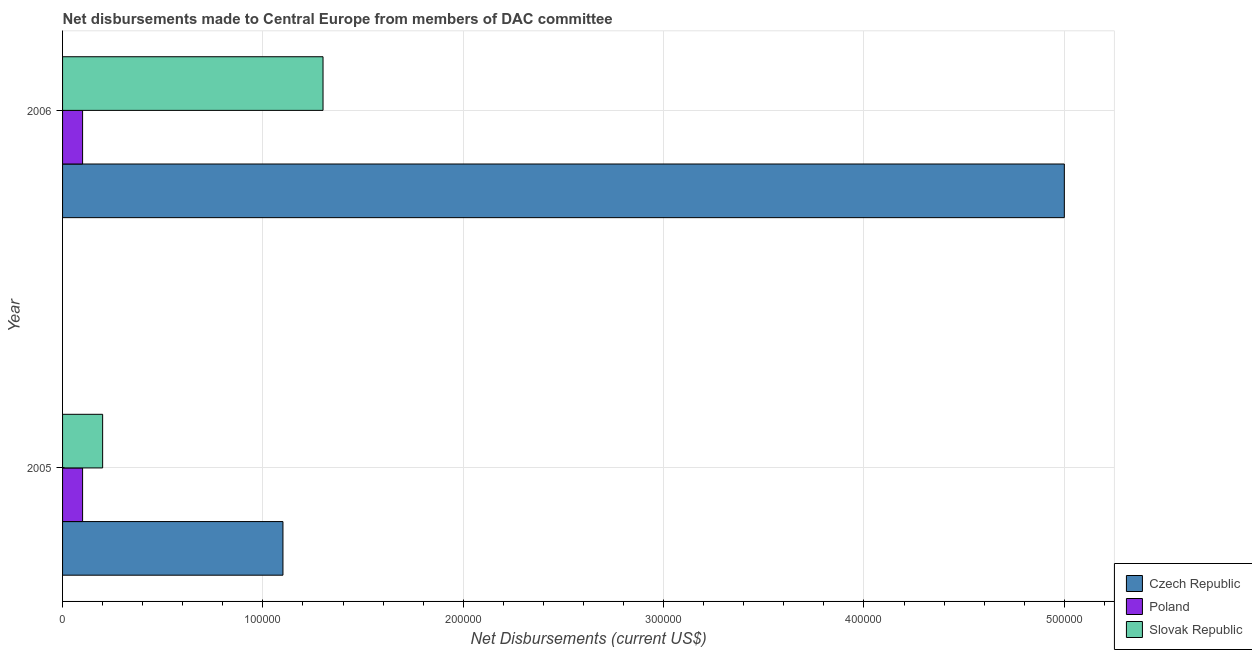Are the number of bars on each tick of the Y-axis equal?
Keep it short and to the point. Yes. What is the label of the 2nd group of bars from the top?
Keep it short and to the point. 2005. In how many cases, is the number of bars for a given year not equal to the number of legend labels?
Your answer should be very brief. 0. What is the net disbursements made by czech republic in 2005?
Ensure brevity in your answer.  1.10e+05. Across all years, what is the maximum net disbursements made by slovak republic?
Ensure brevity in your answer.  1.30e+05. Across all years, what is the minimum net disbursements made by poland?
Give a very brief answer. 10000. What is the total net disbursements made by slovak republic in the graph?
Your response must be concise. 1.50e+05. What is the difference between the net disbursements made by slovak republic in 2005 and that in 2006?
Provide a succinct answer. -1.10e+05. What is the difference between the net disbursements made by slovak republic in 2006 and the net disbursements made by poland in 2005?
Your response must be concise. 1.20e+05. What is the average net disbursements made by poland per year?
Keep it short and to the point. 10000. In the year 2005, what is the difference between the net disbursements made by czech republic and net disbursements made by slovak republic?
Keep it short and to the point. 9.00e+04. What is the ratio of the net disbursements made by slovak republic in 2005 to that in 2006?
Offer a very short reply. 0.15. What does the 3rd bar from the bottom in 2006 represents?
Make the answer very short. Slovak Republic. Are all the bars in the graph horizontal?
Make the answer very short. Yes. How many years are there in the graph?
Keep it short and to the point. 2. Are the values on the major ticks of X-axis written in scientific E-notation?
Your answer should be very brief. No. Does the graph contain any zero values?
Ensure brevity in your answer.  No. Does the graph contain grids?
Provide a succinct answer. Yes. What is the title of the graph?
Provide a succinct answer. Net disbursements made to Central Europe from members of DAC committee. What is the label or title of the X-axis?
Make the answer very short. Net Disbursements (current US$). What is the Net Disbursements (current US$) of Czech Republic in 2005?
Make the answer very short. 1.10e+05. What is the Net Disbursements (current US$) of Czech Republic in 2006?
Provide a succinct answer. 5.00e+05. What is the Net Disbursements (current US$) in Slovak Republic in 2006?
Offer a very short reply. 1.30e+05. Across all years, what is the minimum Net Disbursements (current US$) of Czech Republic?
Provide a short and direct response. 1.10e+05. Across all years, what is the minimum Net Disbursements (current US$) in Slovak Republic?
Your answer should be compact. 2.00e+04. What is the total Net Disbursements (current US$) of Czech Republic in the graph?
Give a very brief answer. 6.10e+05. What is the difference between the Net Disbursements (current US$) in Czech Republic in 2005 and that in 2006?
Offer a terse response. -3.90e+05. What is the difference between the Net Disbursements (current US$) of Czech Republic in 2005 and the Net Disbursements (current US$) of Poland in 2006?
Keep it short and to the point. 1.00e+05. What is the average Net Disbursements (current US$) in Czech Republic per year?
Ensure brevity in your answer.  3.05e+05. What is the average Net Disbursements (current US$) of Slovak Republic per year?
Make the answer very short. 7.50e+04. In the year 2005, what is the difference between the Net Disbursements (current US$) in Czech Republic and Net Disbursements (current US$) in Poland?
Provide a succinct answer. 1.00e+05. In the year 2005, what is the difference between the Net Disbursements (current US$) in Czech Republic and Net Disbursements (current US$) in Slovak Republic?
Ensure brevity in your answer.  9.00e+04. In the year 2006, what is the difference between the Net Disbursements (current US$) of Czech Republic and Net Disbursements (current US$) of Poland?
Make the answer very short. 4.90e+05. What is the ratio of the Net Disbursements (current US$) in Czech Republic in 2005 to that in 2006?
Give a very brief answer. 0.22. What is the ratio of the Net Disbursements (current US$) in Poland in 2005 to that in 2006?
Make the answer very short. 1. What is the ratio of the Net Disbursements (current US$) in Slovak Republic in 2005 to that in 2006?
Provide a succinct answer. 0.15. What is the difference between the highest and the second highest Net Disbursements (current US$) in Slovak Republic?
Keep it short and to the point. 1.10e+05. What is the difference between the highest and the lowest Net Disbursements (current US$) in Poland?
Provide a succinct answer. 0. What is the difference between the highest and the lowest Net Disbursements (current US$) in Slovak Republic?
Keep it short and to the point. 1.10e+05. 